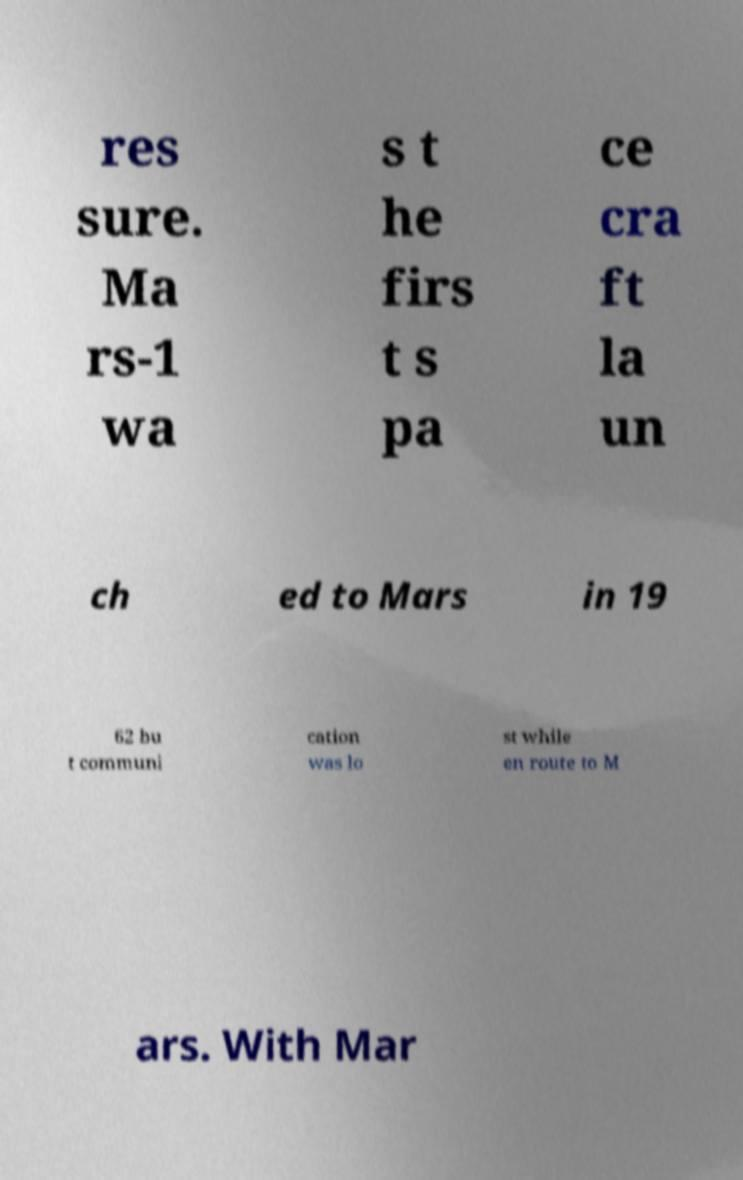Can you read and provide the text displayed in the image?This photo seems to have some interesting text. Can you extract and type it out for me? res sure. Ma rs-1 wa s t he firs t s pa ce cra ft la un ch ed to Mars in 19 62 bu t communi cation was lo st while en route to M ars. With Mar 